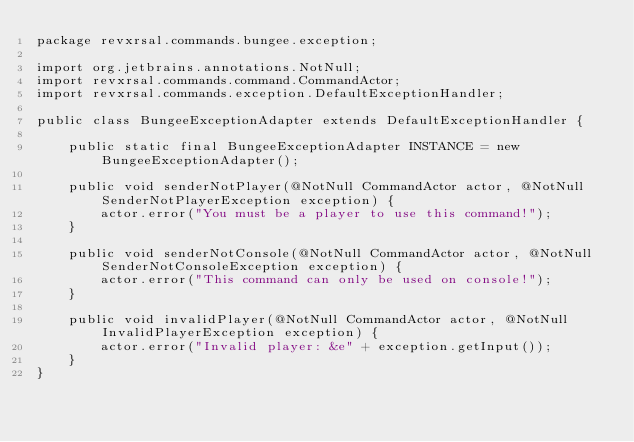Convert code to text. <code><loc_0><loc_0><loc_500><loc_500><_Java_>package revxrsal.commands.bungee.exception;

import org.jetbrains.annotations.NotNull;
import revxrsal.commands.command.CommandActor;
import revxrsal.commands.exception.DefaultExceptionHandler;

public class BungeeExceptionAdapter extends DefaultExceptionHandler {

    public static final BungeeExceptionAdapter INSTANCE = new BungeeExceptionAdapter();

    public void senderNotPlayer(@NotNull CommandActor actor, @NotNull SenderNotPlayerException exception) {
        actor.error("You must be a player to use this command!");
    }

    public void senderNotConsole(@NotNull CommandActor actor, @NotNull SenderNotConsoleException exception) {
        actor.error("This command can only be used on console!");
    }

    public void invalidPlayer(@NotNull CommandActor actor, @NotNull InvalidPlayerException exception) {
        actor.error("Invalid player: &e" + exception.getInput());
    }
}
</code> 